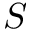<formula> <loc_0><loc_0><loc_500><loc_500>S</formula> 